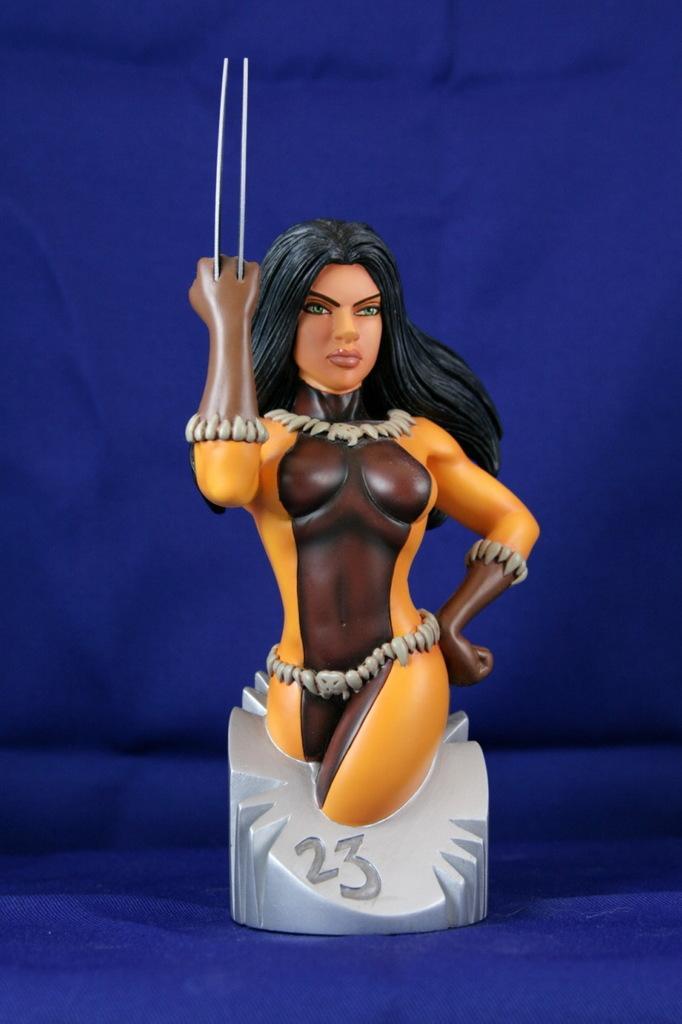In one or two sentences, can you explain what this image depicts? In this picture we can see a toy on a platform and in the background we can see it is blue color. 